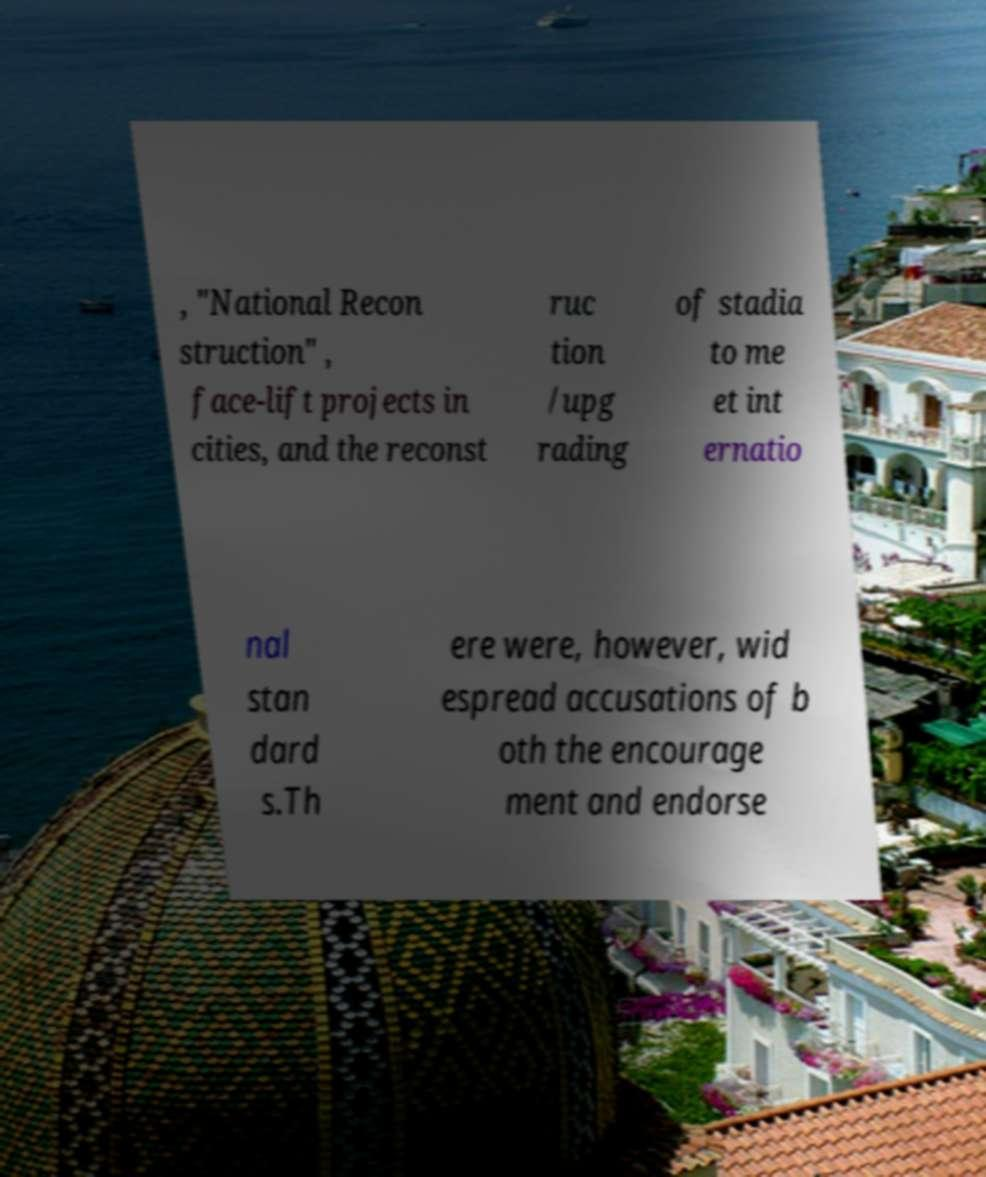I need the written content from this picture converted into text. Can you do that? , "National Recon struction" , face-lift projects in cities, and the reconst ruc tion /upg rading of stadia to me et int ernatio nal stan dard s.Th ere were, however, wid espread accusations of b oth the encourage ment and endorse 